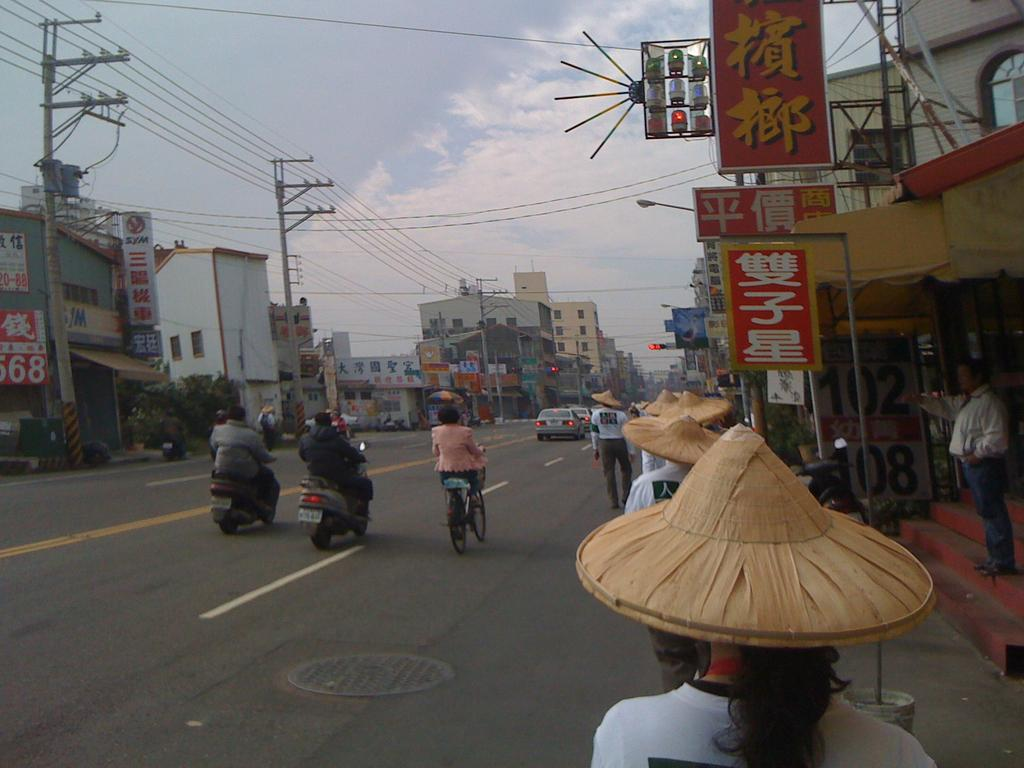<image>
Provide a brief description of the given image. On the left side of the street that last two digits of the sign are 68. 